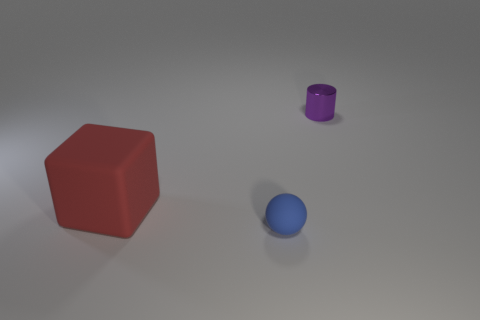Add 1 big red shiny objects. How many objects exist? 4 Subtract all cubes. How many objects are left? 2 Subtract 0 cyan cubes. How many objects are left? 3 Subtract all purple matte objects. Subtract all small balls. How many objects are left? 2 Add 2 large red rubber blocks. How many large red rubber blocks are left? 3 Add 3 cyan shiny blocks. How many cyan shiny blocks exist? 3 